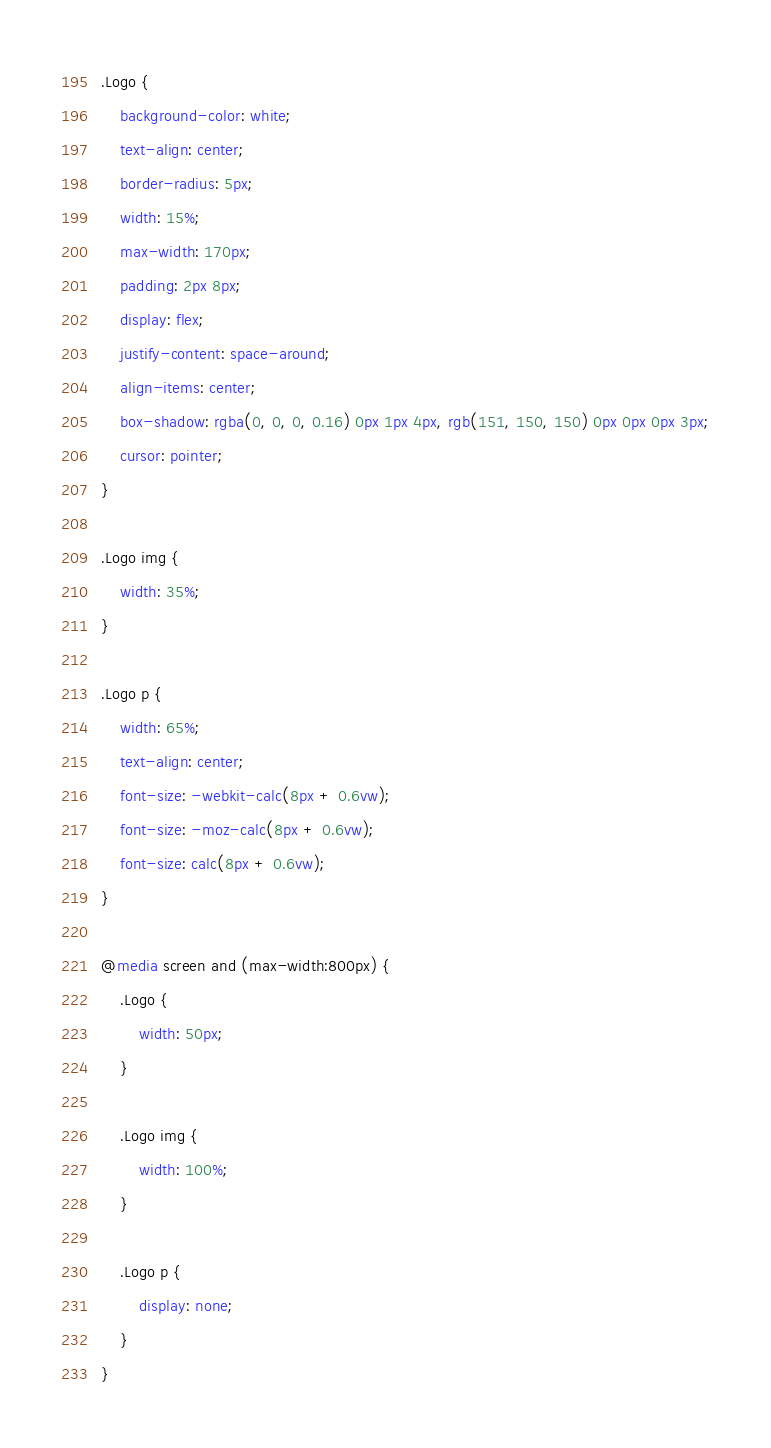<code> <loc_0><loc_0><loc_500><loc_500><_CSS_>.Logo {
    background-color: white;
    text-align: center;
    border-radius: 5px;
    width: 15%;
    max-width: 170px;
    padding: 2px 8px;
    display: flex;
    justify-content: space-around;
    align-items: center;
    box-shadow: rgba(0, 0, 0, 0.16) 0px 1px 4px, rgb(151, 150, 150) 0px 0px 0px 3px;
    cursor: pointer;
}

.Logo img {
    width: 35%;
}

.Logo p {
    width: 65%;
    text-align: center;
    font-size: -webkit-calc(8px + 0.6vw);
    font-size: -moz-calc(8px + 0.6vw);
    font-size: calc(8px + 0.6vw);
}

@media screen and (max-width:800px) {
    .Logo {
        width: 50px;
    }

    .Logo img {
        width: 100%;
    }

    .Logo p {
        display: none;
    }
}</code> 